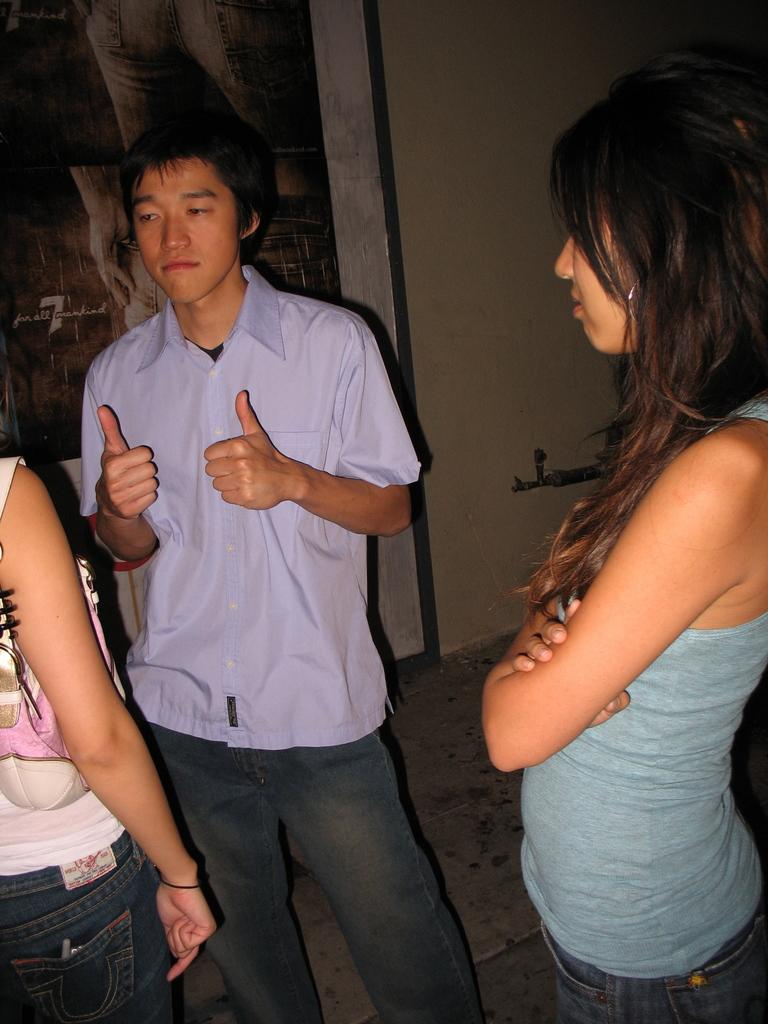How many people are in the image? There are three people in the image. What are the people doing in the image? The people are standing. What are the people wearing in the image? The people are wearing clothes. What type of surface is visible beneath the people? There is a floor visible in the image. What type of structure is visible behind the people? There is a wall visible in the image. What type of fuel is being used by the circle in the image? There is no circle or fuel present in the image. How many rays are emitted by the people in the image? There are no rays emitted by the people in the image. 